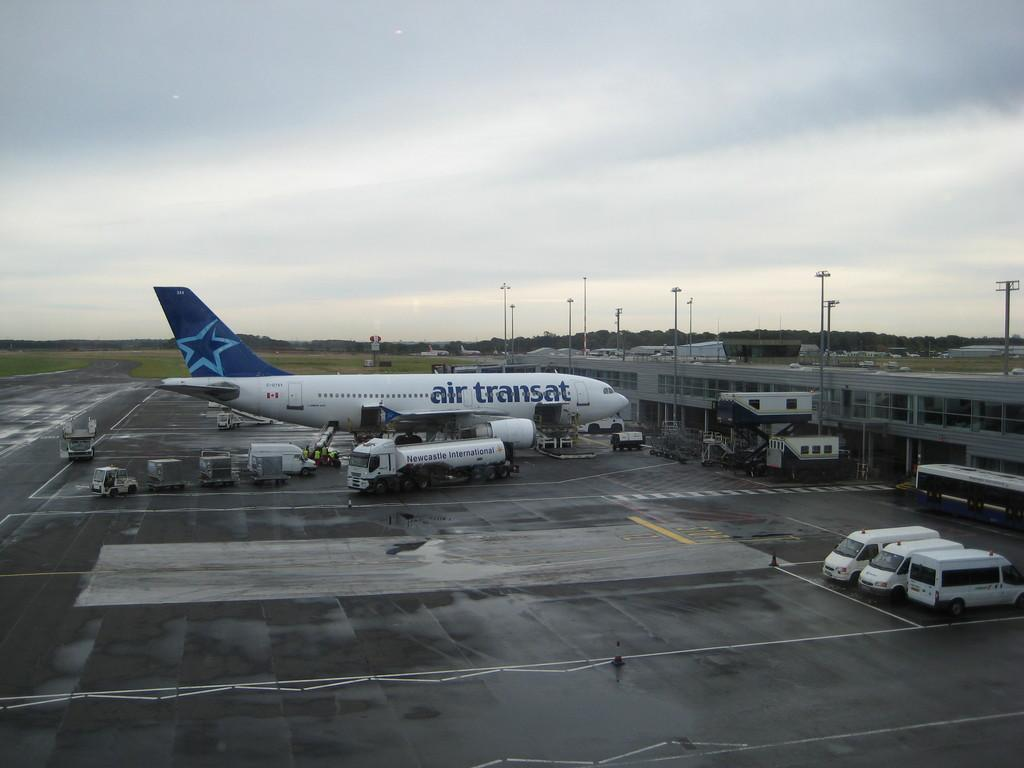<image>
Relay a brief, clear account of the picture shown. An airplane at the airport reads "air transat" on the side. 